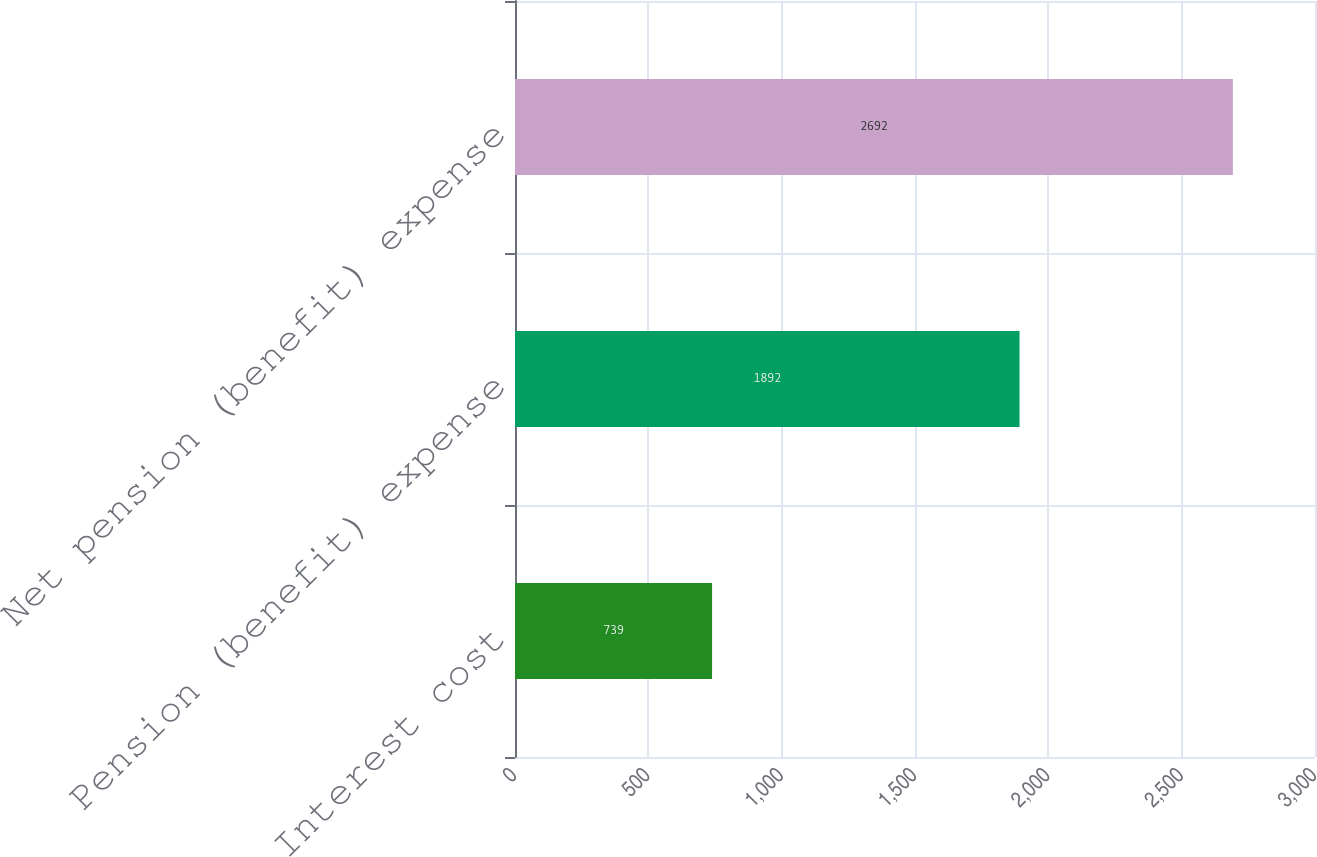Convert chart. <chart><loc_0><loc_0><loc_500><loc_500><bar_chart><fcel>Interest cost<fcel>Pension (benefit) expense<fcel>Net pension (benefit) expense<nl><fcel>739<fcel>1892<fcel>2692<nl></chart> 